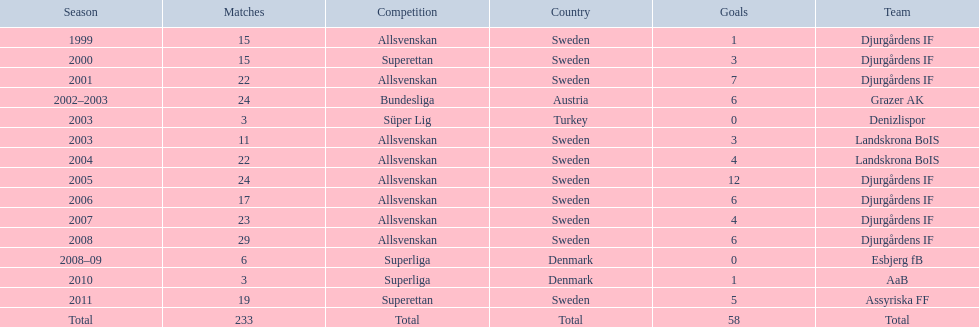Which team holds the record for the most goals scored? Djurgårdens IF. 